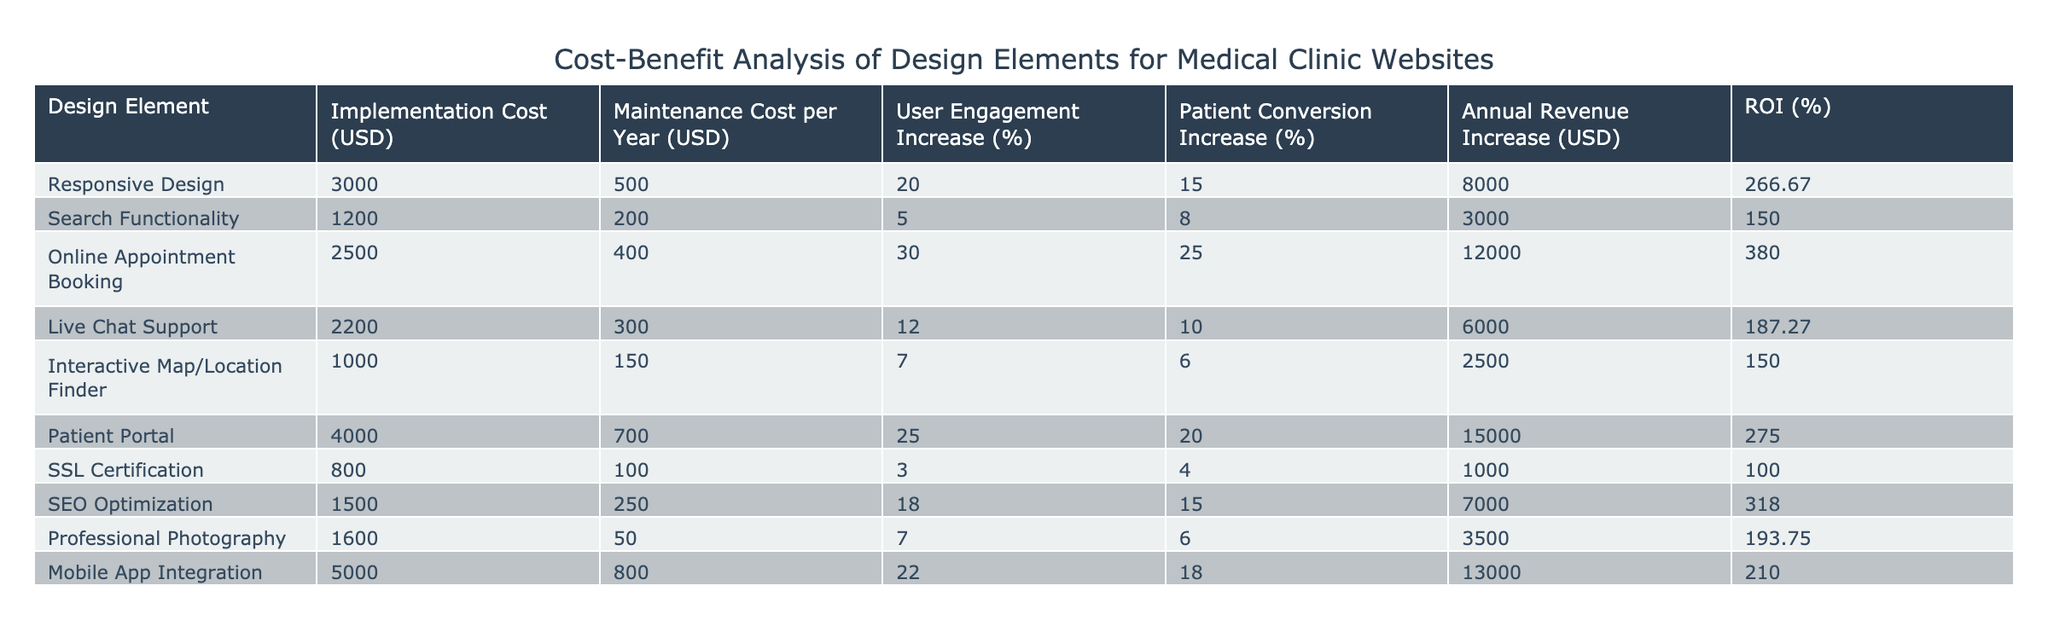What is the implementation cost of the Online Appointment Booking design element? The table shows that the implementation cost associated with the Online Appointment Booking design element is listed under the "Implementation Cost (USD)" column. For Online Appointment Booking, the value is 2500.
Answer: 2500 What is the return on investment (ROI) for the Patient Portal design element? The ROI for the Patient Portal can be found directly in the "ROI (%)" column of the table. For Patient Portal, the ROI is recorded as 275.00.
Answer: 275.00 What design element has the highest annual revenue increase? By comparing the "Annual Revenue Increase (USD)" column, we can identify the design element with the highest value. Online Appointment Booking shows an increase of 12000, which is higher than any other design element.
Answer: Online Appointment Booking How much more does the implementation of Mobile App Integration cost compared to the Interactive Map/Location Finder? To find the difference, we subtract the implementation costs of the two design elements. Mobile App Integration costs 5000, and Interactive Map/Location Finder costs 1000. The difference is 5000 - 1000 = 4000.
Answer: 4000 Is the annual revenue increase for Search Functionality greater than that of SSL Certification? Looking at the "Annual Revenue Increase (USD)" column, Search Functionality shows 3000, and SSL Certification shows 1000. Since 3000 is greater than 1000, the statement is true.
Answer: Yes Which design elements increase user engagement by more than 20%? We need to check the "User Engagement Increase (%)" column for values greater than 20%. The only design element that meets this criterion is Online Appointment Booking, which has a 30% increase.
Answer: Online Appointment Booking What is the average maintenance cost per year for all the design elements listed? To calculate the average maintenance cost per year, we sum the maintenance costs for each design element and then divide by the number of elements. The maintenance costs are 500, 200, 400, 300, 150, 700, 100, 250, 50, 800. Summing these gives 3000, and dividing by 10 results in an average of 300.
Answer: 300 How many design elements have an ROI of more than 250%? By reviewing the "ROI (%)" column, we find that the elements with ROI greater than 250% include Responsive Design (266.67), Online Appointment Booking (380.00), and Patient Portal (275.00). That gives us three design elements.
Answer: 3 